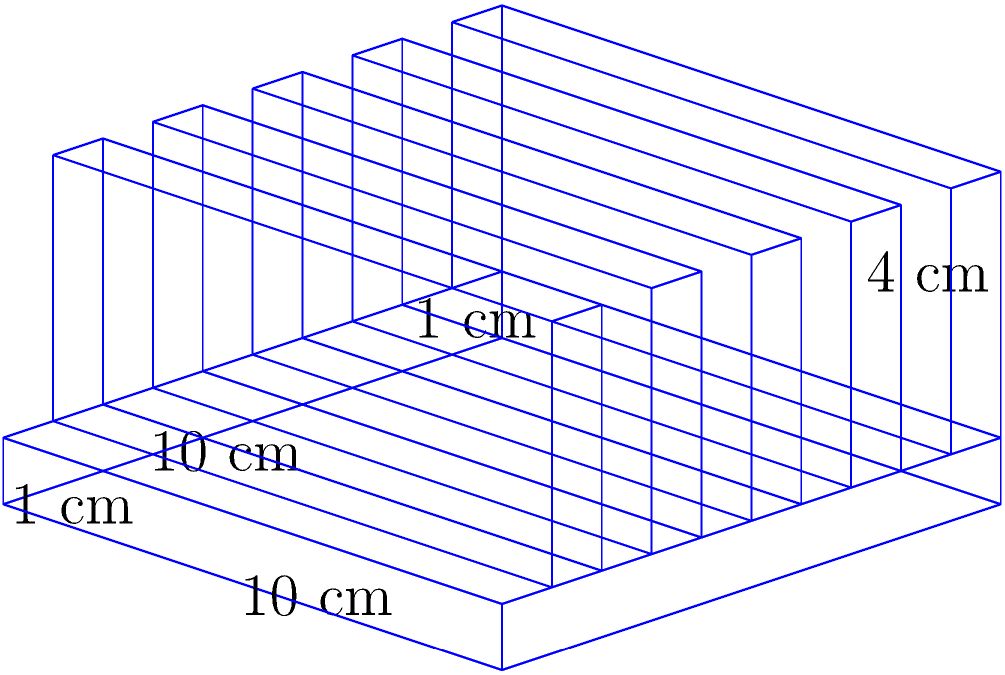A heat sink for a high-power electronic component has a square base of 10 cm × 10 cm and a thickness of 1 cm. It has 5 equally spaced fins, each 1 cm thick and 4 cm tall. Calculate the total surface area of the heat sink in cm². Assume all surfaces contribute to heat dissipation. Let's break this down step-by-step:

1) Surface area of the base:
   - Top: $10 \text{ cm} \times 10 \text{ cm} = 100 \text{ cm}^2$
   - Bottom: $10 \text{ cm} \times 10 \text{ cm} = 100 \text{ cm}^2$
   - 4 sides: $4 \times (10 \text{ cm} \times 1 \text{ cm}) = 40 \text{ cm}^2$
   Total base area: $100 + 100 + 40 = 240 \text{ cm}^2$

2) Surface area of each fin:
   - 2 large faces: $2 \times (10 \text{ cm} \times 4 \text{ cm}) = 80 \text{ cm}^2$
   - Top: $10 \text{ cm} \times 1 \text{ cm} = 10 \text{ cm}^2$
   - 2 small ends: $2 \times (4 \text{ cm} \times 1 \text{ cm}) = 8 \text{ cm}^2$
   Total area per fin: $80 + 10 + 8 = 98 \text{ cm}^2$

3) Total surface area of all fins:
   $5 \times 98 \text{ cm}^2 = 490 \text{ cm}^2$

4) Area between fins on the base:
   $4 \times (10 \text{ cm} \times 1 \text{ cm}) = 40 \text{ cm}^2$

5) Total surface area:
   Base + All fins + Area between fins
   $240 \text{ cm}^2 + 490 \text{ cm}^2 + 40 \text{ cm}^2 = 770 \text{ cm}^2$
Answer: $770 \text{ cm}^2$ 